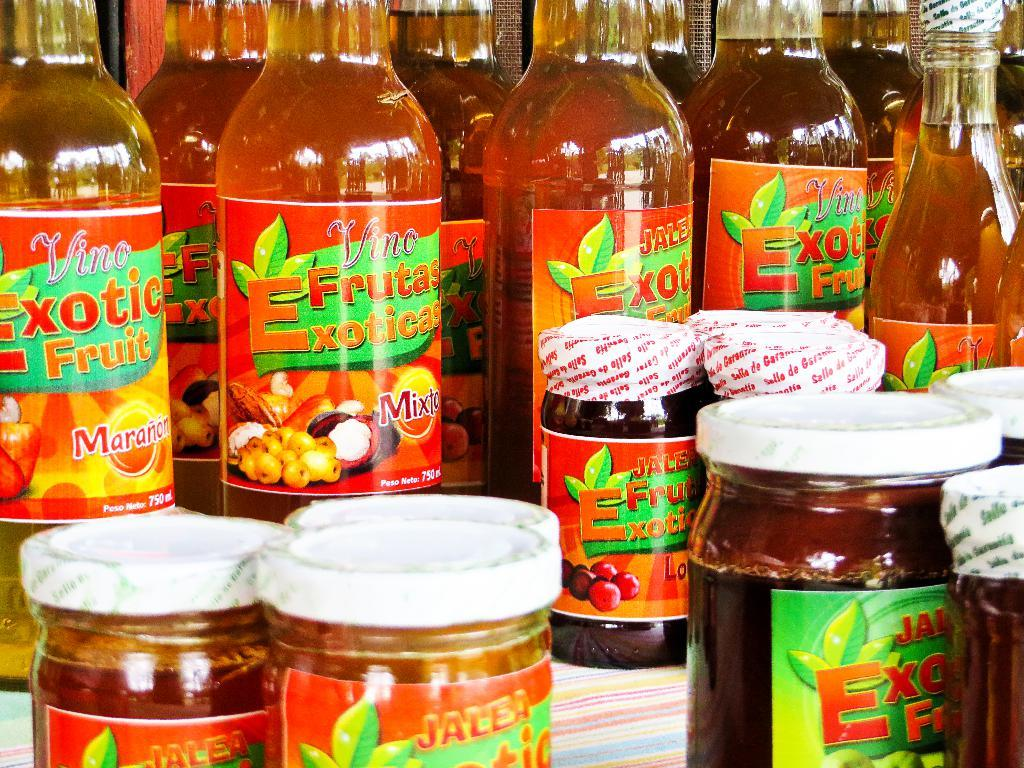What type of food items are present in the image? There are exotic fruits in the image. What else can be seen in the image besides the fruits? There are bottles and jars in the image. How are the jars positioned in the image? The jars are placed on some cloth in the image. What type of class is being held in the image? There is no class or any indication of a class being held in the image. 